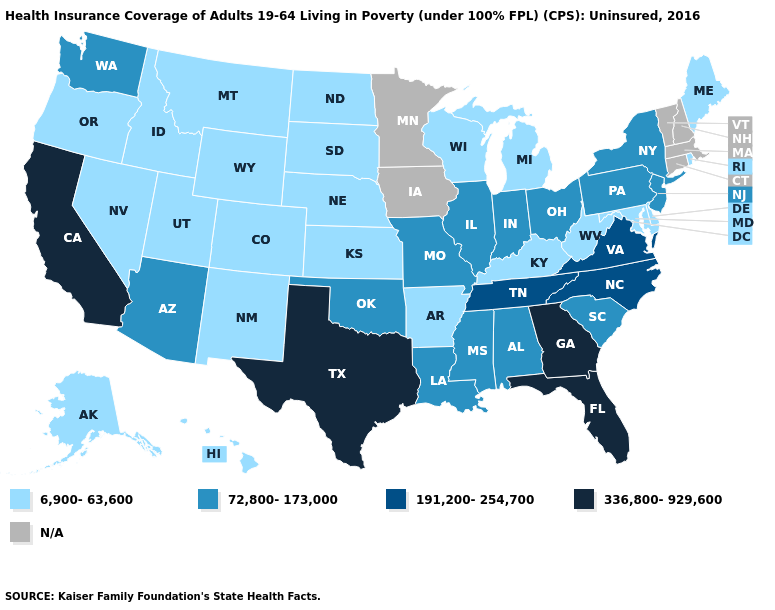What is the value of New Jersey?
Quick response, please. 72,800-173,000. Is the legend a continuous bar?
Give a very brief answer. No. Does the map have missing data?
Concise answer only. Yes. What is the value of Rhode Island?
Answer briefly. 6,900-63,600. What is the lowest value in the USA?
Keep it brief. 6,900-63,600. Name the states that have a value in the range 336,800-929,600?
Quick response, please. California, Florida, Georgia, Texas. Does Georgia have the highest value in the USA?
Be succinct. Yes. Does New Jersey have the lowest value in the Northeast?
Write a very short answer. No. Name the states that have a value in the range N/A?
Keep it brief. Connecticut, Iowa, Massachusetts, Minnesota, New Hampshire, Vermont. Which states have the highest value in the USA?
Give a very brief answer. California, Florida, Georgia, Texas. What is the highest value in the Northeast ?
Give a very brief answer. 72,800-173,000. What is the lowest value in the USA?
Keep it brief. 6,900-63,600. Which states have the highest value in the USA?
Keep it brief. California, Florida, Georgia, Texas. Does Oklahoma have the lowest value in the USA?
Concise answer only. No. What is the value of Delaware?
Give a very brief answer. 6,900-63,600. 